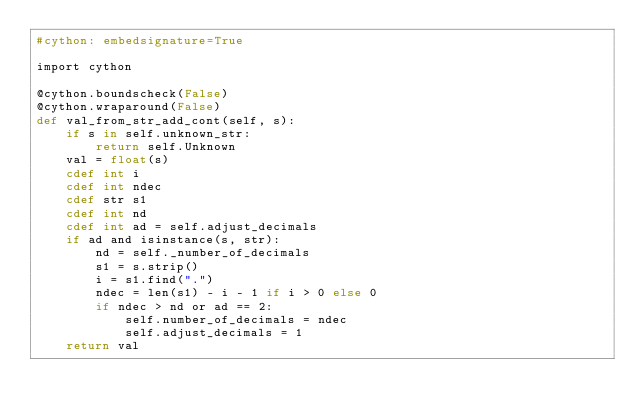Convert code to text. <code><loc_0><loc_0><loc_500><loc_500><_Cython_>#cython: embedsignature=True

import cython

@cython.boundscheck(False)
@cython.wraparound(False)
def val_from_str_add_cont(self, s):
    if s in self.unknown_str:
        return self.Unknown
    val = float(s)
    cdef int i
    cdef int ndec
    cdef str s1
    cdef int nd
    cdef int ad = self.adjust_decimals
    if ad and isinstance(s, str):
        nd = self._number_of_decimals
        s1 = s.strip()
        i = s1.find(".")
        ndec = len(s1) - i - 1 if i > 0 else 0
        if ndec > nd or ad == 2:
            self.number_of_decimals = ndec
            self.adjust_decimals = 1
    return val
</code> 